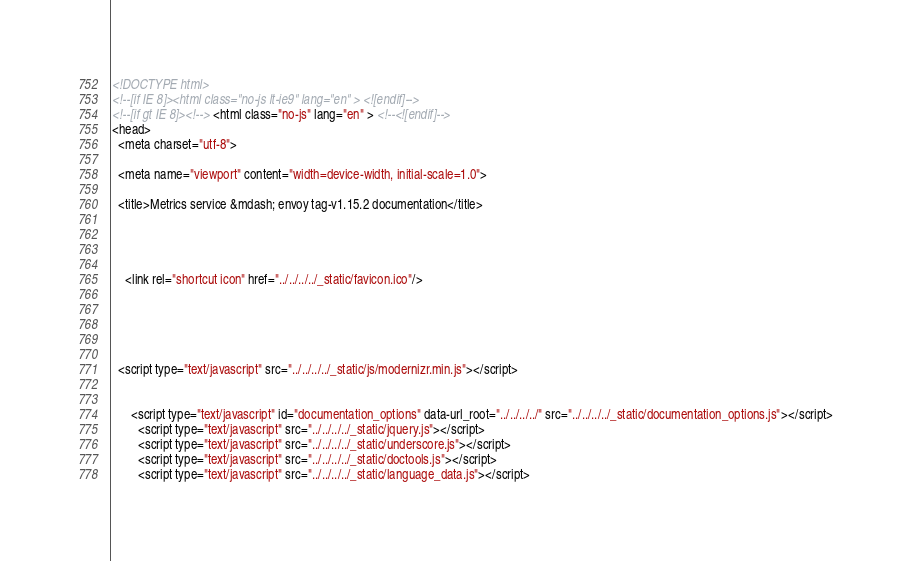<code> <loc_0><loc_0><loc_500><loc_500><_HTML_>

<!DOCTYPE html>
<!--[if IE 8]><html class="no-js lt-ie9" lang="en" > <![endif]-->
<!--[if gt IE 8]><!--> <html class="no-js" lang="en" > <!--<![endif]-->
<head>
  <meta charset="utf-8">
  
  <meta name="viewport" content="width=device-width, initial-scale=1.0">
  
  <title>Metrics service &mdash; envoy tag-v1.15.2 documentation</title>
  

  
  
    <link rel="shortcut icon" href="../../../../_static/favicon.ico"/>
  
  
  

  
  <script type="text/javascript" src="../../../../_static/js/modernizr.min.js"></script>
  
    
      <script type="text/javascript" id="documentation_options" data-url_root="../../../../" src="../../../../_static/documentation_options.js"></script>
        <script type="text/javascript" src="../../../../_static/jquery.js"></script>
        <script type="text/javascript" src="../../../../_static/underscore.js"></script>
        <script type="text/javascript" src="../../../../_static/doctools.js"></script>
        <script type="text/javascript" src="../../../../_static/language_data.js"></script></code> 